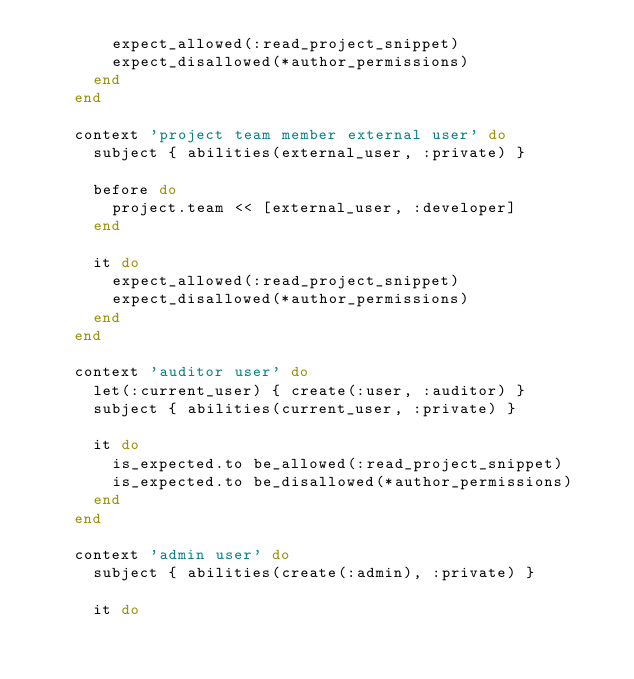<code> <loc_0><loc_0><loc_500><loc_500><_Ruby_>        expect_allowed(:read_project_snippet)
        expect_disallowed(*author_permissions)
      end
    end

    context 'project team member external user' do
      subject { abilities(external_user, :private) }

      before do
        project.team << [external_user, :developer]
      end

      it do
        expect_allowed(:read_project_snippet)
        expect_disallowed(*author_permissions)
      end
    end

    context 'auditor user' do
      let(:current_user) { create(:user, :auditor) }
      subject { abilities(current_user, :private) }

      it do
        is_expected.to be_allowed(:read_project_snippet)
        is_expected.to be_disallowed(*author_permissions)
      end
    end

    context 'admin user' do
      subject { abilities(create(:admin), :private) }

      it do</code> 